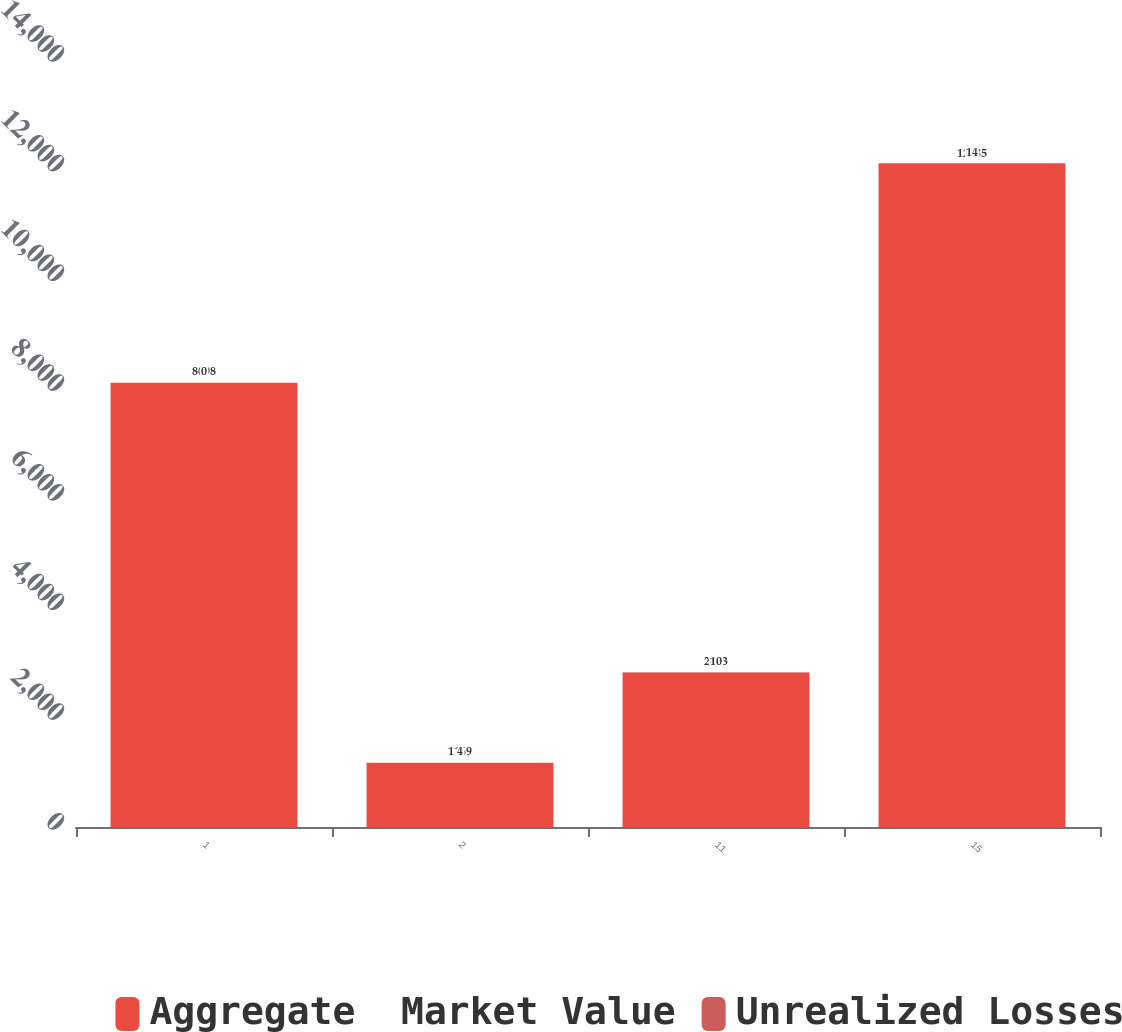<chart> <loc_0><loc_0><loc_500><loc_500><stacked_bar_chart><ecel><fcel>1<fcel>2<fcel>11<fcel>15<nl><fcel>Aggregate  Market Value<fcel>8098<fcel>1169<fcel>2813<fcel>12085<nl><fcel>Unrealized Losses<fcel>0<fcel>4<fcel>10<fcel>14<nl></chart> 